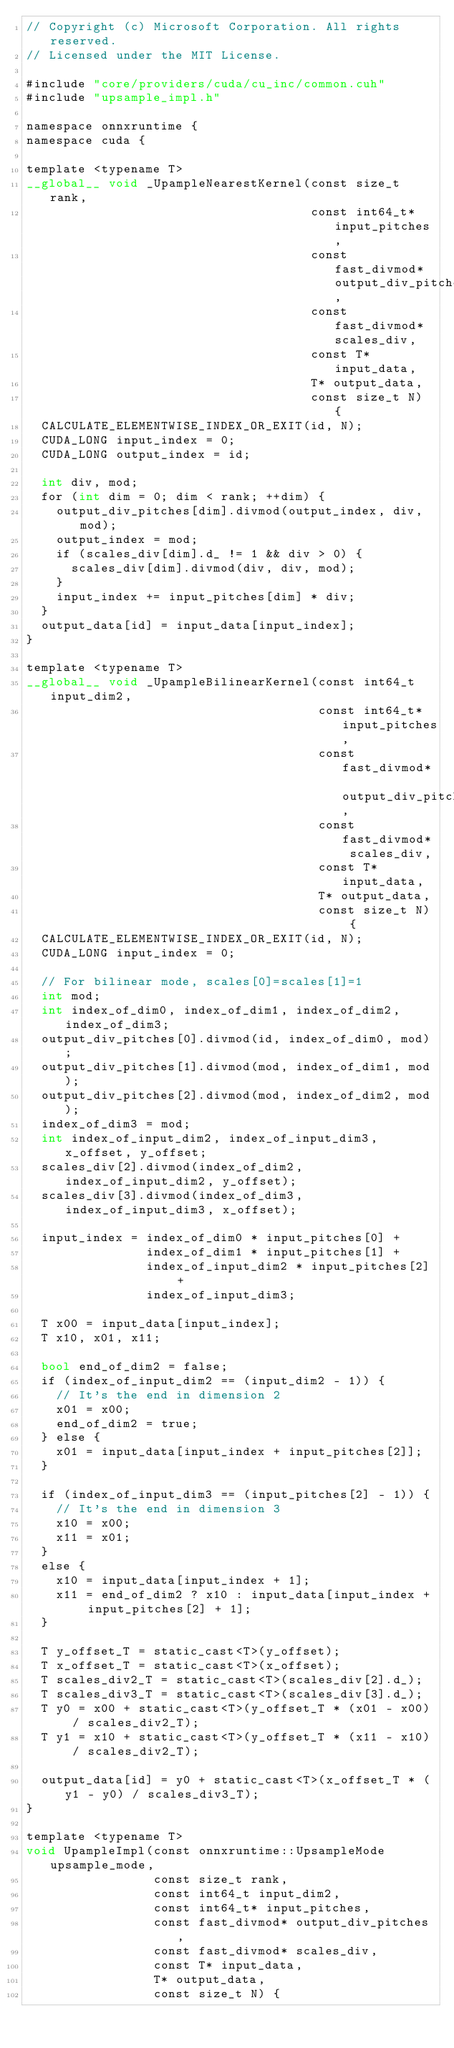Convert code to text. <code><loc_0><loc_0><loc_500><loc_500><_Cuda_>// Copyright (c) Microsoft Corporation. All rights reserved.
// Licensed under the MIT License.

#include "core/providers/cuda/cu_inc/common.cuh"
#include "upsample_impl.h"

namespace onnxruntime {
namespace cuda {

template <typename T>
__global__ void _UpampleNearestKernel(const size_t rank,
                                      const int64_t* input_pitches,
                                      const fast_divmod* output_div_pitches,
                                      const fast_divmod* scales_div,
                                      const T* input_data,
                                      T* output_data,
                                      const size_t N) {
  CALCULATE_ELEMENTWISE_INDEX_OR_EXIT(id, N);
  CUDA_LONG input_index = 0;
  CUDA_LONG output_index = id;

  int div, mod;
  for (int dim = 0; dim < rank; ++dim) {
    output_div_pitches[dim].divmod(output_index, div, mod);
    output_index = mod;
    if (scales_div[dim].d_ != 1 && div > 0) {
      scales_div[dim].divmod(div, div, mod); 
    }
    input_index += input_pitches[dim] * div;
  }
  output_data[id] = input_data[input_index];
}

template <typename T>
__global__ void _UpampleBilinearKernel(const int64_t input_dim2,
                                       const int64_t* input_pitches,
                                       const fast_divmod* output_div_pitches,
                                       const fast_divmod* scales_div,
                                       const T* input_data,
                                       T* output_data,
                                       const size_t N) {
  CALCULATE_ELEMENTWISE_INDEX_OR_EXIT(id, N);
  CUDA_LONG input_index = 0;

  // For bilinear mode, scales[0]=scales[1]=1
  int mod;
  int index_of_dim0, index_of_dim1, index_of_dim2, index_of_dim3;
  output_div_pitches[0].divmod(id, index_of_dim0, mod);
  output_div_pitches[1].divmod(mod, index_of_dim1, mod);
  output_div_pitches[2].divmod(mod, index_of_dim2, mod);
  index_of_dim3 = mod;
  int index_of_input_dim2, index_of_input_dim3, x_offset, y_offset;
  scales_div[2].divmod(index_of_dim2, index_of_input_dim2, y_offset);
  scales_div[3].divmod(index_of_dim3, index_of_input_dim3, x_offset);

  input_index = index_of_dim0 * input_pitches[0] +
                index_of_dim1 * input_pitches[1] +
                index_of_input_dim2 * input_pitches[2] +
                index_of_input_dim3;
  
  T x00 = input_data[input_index];
  T x10, x01, x11;

  bool end_of_dim2 = false;
  if (index_of_input_dim2 == (input_dim2 - 1)) {
    // It's the end in dimension 2
    x01 = x00;
    end_of_dim2 = true;
  } else {
    x01 = input_data[input_index + input_pitches[2]];
  }

  if (index_of_input_dim3 == (input_pitches[2] - 1)) {
    // It's the end in dimension 3
    x10 = x00;
    x11 = x01;
  }
  else {
    x10 = input_data[input_index + 1];
    x11 = end_of_dim2 ? x10 : input_data[input_index + input_pitches[2] + 1];
  }

  T y_offset_T = static_cast<T>(y_offset);
  T x_offset_T = static_cast<T>(x_offset);
  T scales_div2_T = static_cast<T>(scales_div[2].d_);
  T scales_div3_T = static_cast<T>(scales_div[3].d_);
  T y0 = x00 + static_cast<T>(y_offset_T * (x01 - x00) / scales_div2_T);
  T y1 = x10 + static_cast<T>(y_offset_T * (x11 - x10) / scales_div2_T);

  output_data[id] = y0 + static_cast<T>(x_offset_T * (y1 - y0) / scales_div3_T);
}

template <typename T>
void UpampleImpl(const onnxruntime::UpsampleMode upsample_mode,
                 const size_t rank,
                 const int64_t input_dim2,
                 const int64_t* input_pitches,
                 const fast_divmod* output_div_pitches,
                 const fast_divmod* scales_div,
                 const T* input_data,
                 T* output_data,
                 const size_t N) {</code> 